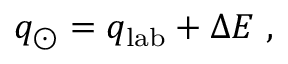<formula> <loc_0><loc_0><loc_500><loc_500>q _ { \odot } = q _ { l a b } + \Delta E ,</formula> 